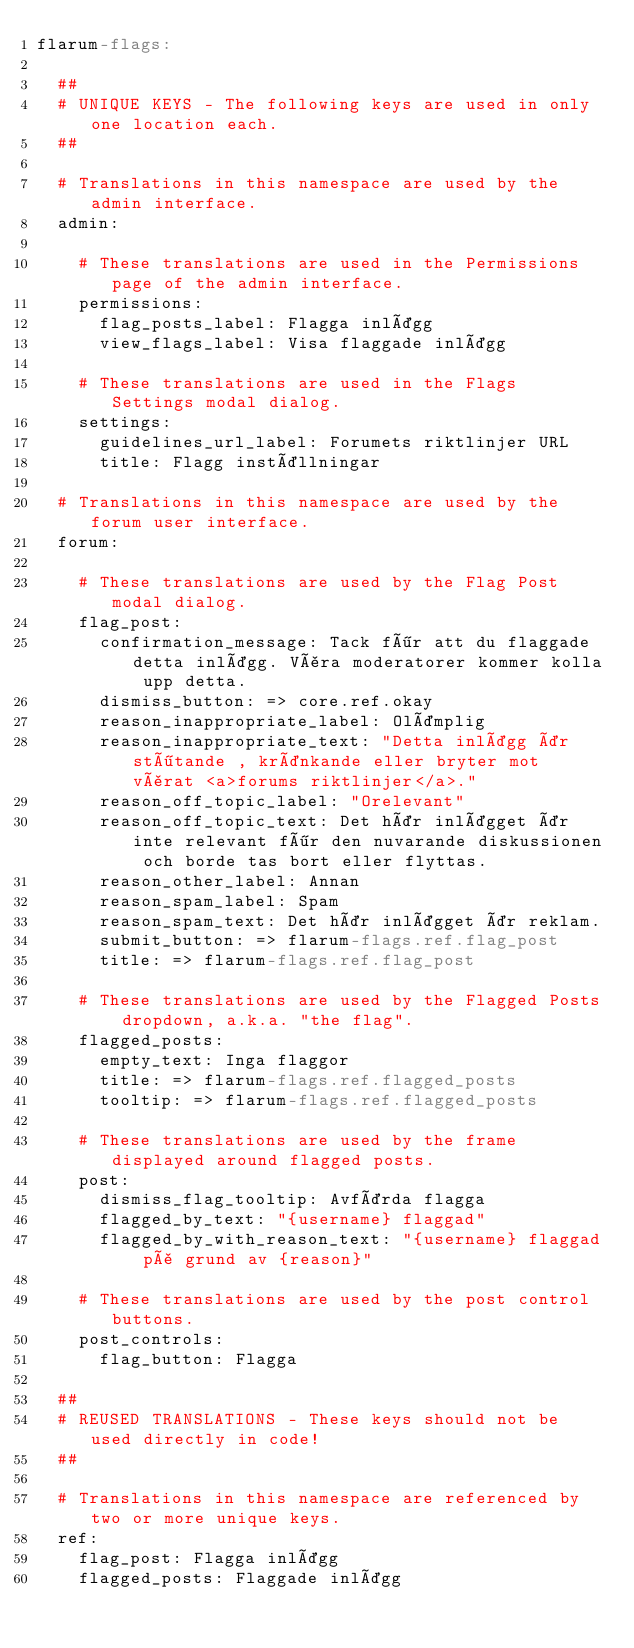<code> <loc_0><loc_0><loc_500><loc_500><_YAML_>flarum-flags:

  ##
  # UNIQUE KEYS - The following keys are used in only one location each.
  ##

  # Translations in this namespace are used by the admin interface.
  admin:

    # These translations are used in the Permissions page of the admin interface.
    permissions:
      flag_posts_label: Flagga inlägg
      view_flags_label: Visa flaggade inlägg

    # These translations are used in the Flags Settings modal dialog.
    settings:
      guidelines_url_label: Forumets riktlinjer URL
      title: Flagg inställningar

  # Translations in this namespace are used by the forum user interface.
  forum:

    # These translations are used by the Flag Post modal dialog.
    flag_post:
      confirmation_message: Tack för att du flaggade detta inlägg. Våra moderatorer kommer kolla upp detta.
      dismiss_button: => core.ref.okay
      reason_inappropriate_label: Olämplig
      reason_inappropriate_text: "Detta inlägg är stötande , kränkande eller bryter mot vårat <a>forums riktlinjer</a>."
      reason_off_topic_label: "Orelevant"
      reason_off_topic_text: Det här inlägget är inte relevant för den nuvarande diskussionen och borde tas bort eller flyttas.
      reason_other_label: Annan
      reason_spam_label: Spam
      reason_spam_text: Det här inlägget är reklam.
      submit_button: => flarum-flags.ref.flag_post
      title: => flarum-flags.ref.flag_post

    # These translations are used by the Flagged Posts dropdown, a.k.a. "the flag".
    flagged_posts:
      empty_text: Inga flaggor
      title: => flarum-flags.ref.flagged_posts
      tooltip: => flarum-flags.ref.flagged_posts

    # These translations are used by the frame displayed around flagged posts.
    post:
      dismiss_flag_tooltip: Avfärda flagga
      flagged_by_text: "{username} flaggad"
      flagged_by_with_reason_text: "{username} flaggad på grund av {reason}"

    # These translations are used by the post control buttons.
    post_controls:
      flag_button: Flagga

  ##
  # REUSED TRANSLATIONS - These keys should not be used directly in code!
  ##

  # Translations in this namespace are referenced by two or more unique keys.
  ref:
    flag_post: Flagga inlägg
    flagged_posts: Flaggade inlägg
</code> 